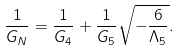<formula> <loc_0><loc_0><loc_500><loc_500>\frac { 1 } { G _ { N } } = \frac { 1 } { G _ { 4 } } + \frac { 1 } { G _ { 5 } } \sqrt { - \frac { 6 } { \Lambda _ { 5 } } } .</formula> 